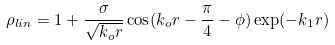Convert formula to latex. <formula><loc_0><loc_0><loc_500><loc_500>\rho _ { l i n } = 1 + \frac { \sigma } { \sqrt { k _ { o } r } } \cos ( k _ { o } r - \frac { \pi } { 4 } - \phi ) \exp ( - k _ { 1 } r )</formula> 